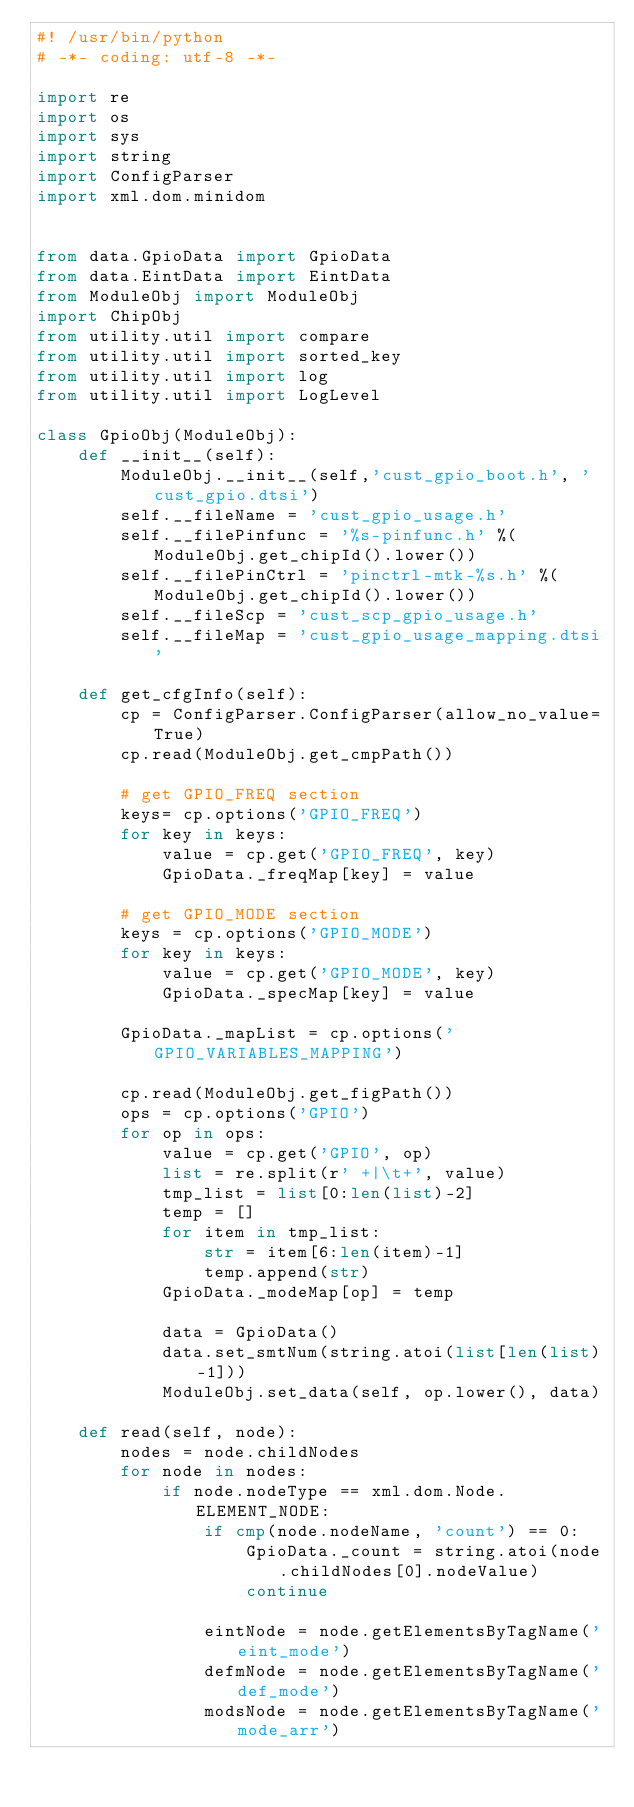<code> <loc_0><loc_0><loc_500><loc_500><_Python_>#! /usr/bin/python
# -*- coding: utf-8 -*-

import re
import os
import sys
import string
import ConfigParser
import xml.dom.minidom


from data.GpioData import GpioData
from data.EintData import EintData
from ModuleObj import ModuleObj
import ChipObj
from utility.util import compare
from utility.util import sorted_key
from utility.util import log
from utility.util import LogLevel

class GpioObj(ModuleObj):
    def __init__(self):
        ModuleObj.__init__(self,'cust_gpio_boot.h', 'cust_gpio.dtsi')
        self.__fileName = 'cust_gpio_usage.h'
        self.__filePinfunc = '%s-pinfunc.h' %(ModuleObj.get_chipId().lower())
        self.__filePinCtrl = 'pinctrl-mtk-%s.h' %(ModuleObj.get_chipId().lower())
        self.__fileScp = 'cust_scp_gpio_usage.h'
        self.__fileMap = 'cust_gpio_usage_mapping.dtsi'

    def get_cfgInfo(self):
        cp = ConfigParser.ConfigParser(allow_no_value=True)
        cp.read(ModuleObj.get_cmpPath())

        # get GPIO_FREQ section
        keys= cp.options('GPIO_FREQ')
        for key in keys:
            value = cp.get('GPIO_FREQ', key)
            GpioData._freqMap[key] = value

        # get GPIO_MODE section
        keys = cp.options('GPIO_MODE')
        for key in keys:
            value = cp.get('GPIO_MODE', key)
            GpioData._specMap[key] = value

        GpioData._mapList = cp.options('GPIO_VARIABLES_MAPPING')

        cp.read(ModuleObj.get_figPath())
        ops = cp.options('GPIO')
        for op in ops:
            value = cp.get('GPIO', op)
            list = re.split(r' +|\t+', value)
            tmp_list = list[0:len(list)-2]
            temp = []
            for item in tmp_list:
                str = item[6:len(item)-1]
                temp.append(str)
            GpioData._modeMap[op] = temp

            data = GpioData()
            data.set_smtNum(string.atoi(list[len(list)-1]))
            ModuleObj.set_data(self, op.lower(), data)

    def read(self, node):
        nodes = node.childNodes
        for node in nodes:
            if node.nodeType == xml.dom.Node.ELEMENT_NODE:
                if cmp(node.nodeName, 'count') == 0:
                    GpioData._count = string.atoi(node.childNodes[0].nodeValue)
                    continue

                eintNode = node.getElementsByTagName('eint_mode')
                defmNode = node.getElementsByTagName('def_mode')
                modsNode = node.getElementsByTagName('mode_arr')</code> 